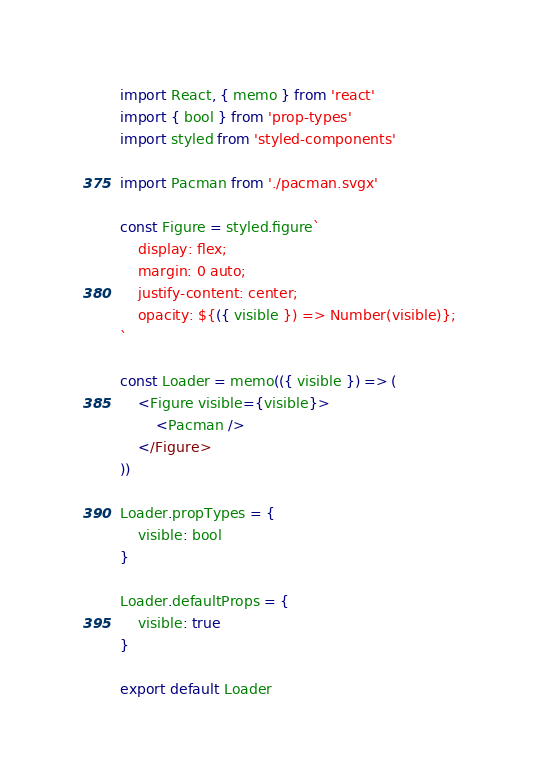<code> <loc_0><loc_0><loc_500><loc_500><_JavaScript_>import React, { memo } from 'react'
import { bool } from 'prop-types'
import styled from 'styled-components'

import Pacman from './pacman.svgx'

const Figure = styled.figure`
    display: flex;
    margin: 0 auto;
    justify-content: center;
    opacity: ${({ visible }) => Number(visible)};
`

const Loader = memo(({ visible }) => (
    <Figure visible={visible}>
        <Pacman />
    </Figure>
))

Loader.propTypes = {
    visible: bool
}

Loader.defaultProps = {
    visible: true
}

export default Loader
</code> 